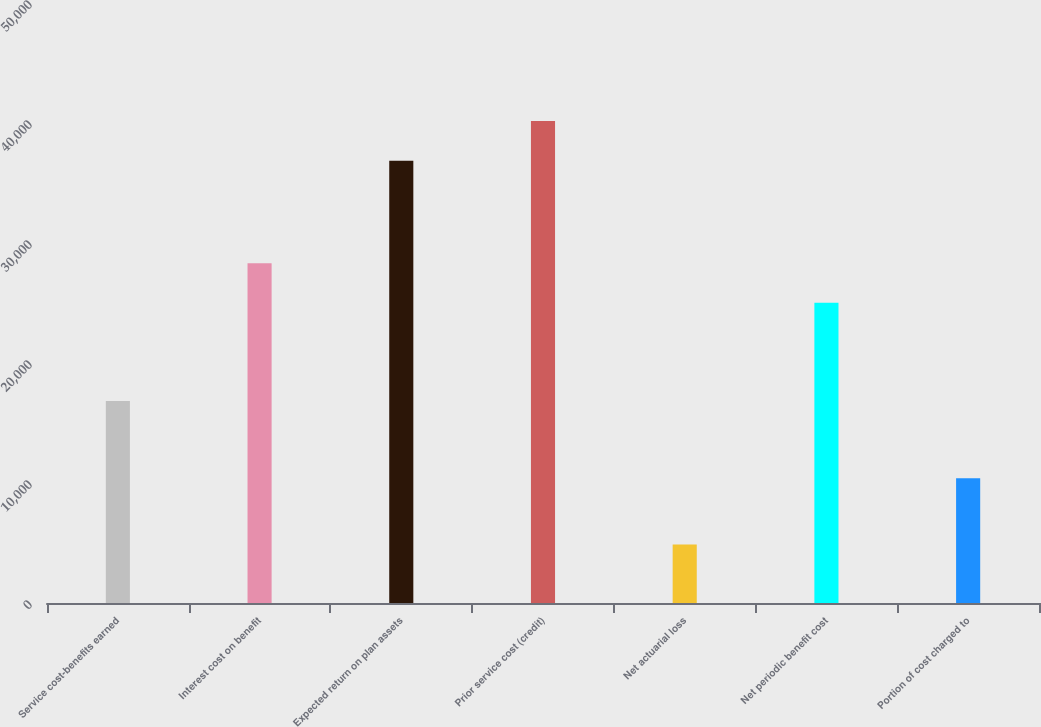<chart> <loc_0><loc_0><loc_500><loc_500><bar_chart><fcel>Service cost-benefits earned<fcel>Interest cost on benefit<fcel>Expected return on plan assets<fcel>Prior service cost (credit)<fcel>Net actuarial loss<fcel>Net periodic benefit cost<fcel>Portion of cost charged to<nl><fcel>16827<fcel>28321.7<fcel>36855<fcel>40163.7<fcel>4881<fcel>25013<fcel>10391<nl></chart> 